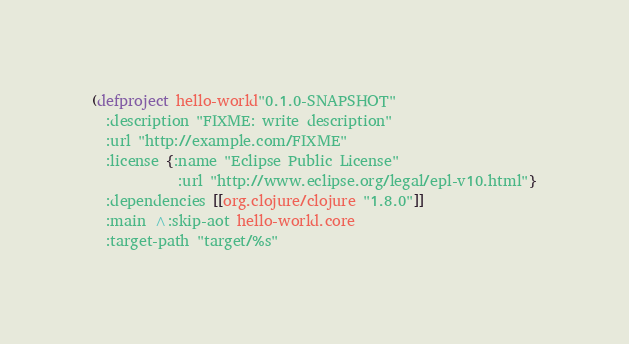<code> <loc_0><loc_0><loc_500><loc_500><_Clojure_>(defproject hello-world"0.1.0-SNAPSHOT"
  :description "FIXME: write description"
  :url "http://example.com/FIXME"
  :license {:name "Eclipse Public License"
            :url "http://www.eclipse.org/legal/epl-v10.html"}
  :dependencies [[org.clojure/clojure "1.8.0"]]
  :main ^:skip-aot hello-world.core
  :target-path "target/%s"</code> 